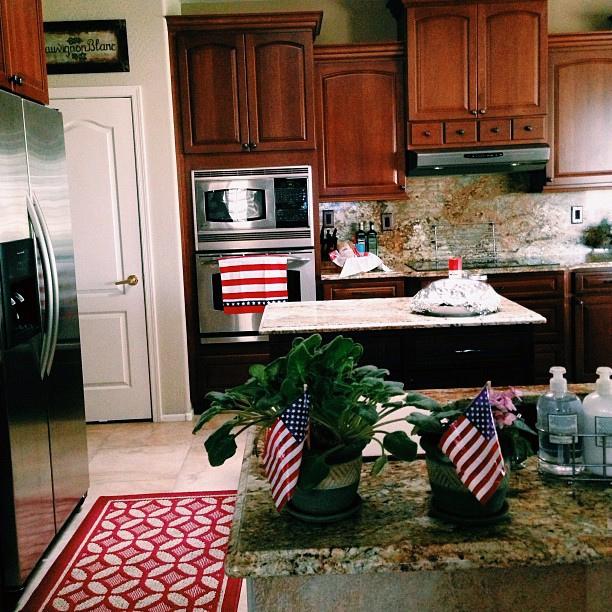Is there a cake on the table?
Write a very short answer. Yes. How many rugs are there?
Keep it brief. 1. How many flags are there?
Concise answer only. 2. 